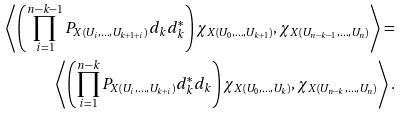<formula> <loc_0><loc_0><loc_500><loc_500>\left \langle \left ( \prod _ { i = 1 } ^ { n - k - 1 } P _ { X ( U _ { i } , \dots , U _ { k + 1 + i } ) } d _ { k } d ^ { * } _ { k } \right ) \chi _ { X ( U _ { 0 } , \dots , U _ { k + 1 } ) } , \chi _ { X ( U _ { n - k - 1 } , \dots , U _ { n } ) } \right \rangle = \\ \left \langle \left ( \prod _ { i = 1 } ^ { n - k } P _ { X ( U _ { i } , \dots , U _ { k + i } ) } d _ { k } ^ { * } d _ { k } \right ) \chi _ { X ( U _ { 0 } , \dots , U _ { k } ) } , \chi _ { X ( U _ { n - k } , \dots , U _ { n } ) } \right \rangle .</formula> 